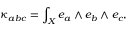<formula> <loc_0><loc_0><loc_500><loc_500>\kappa _ { a b c } = \int _ { X } e _ { a } \wedge e _ { b } \wedge e _ { c } ,</formula> 